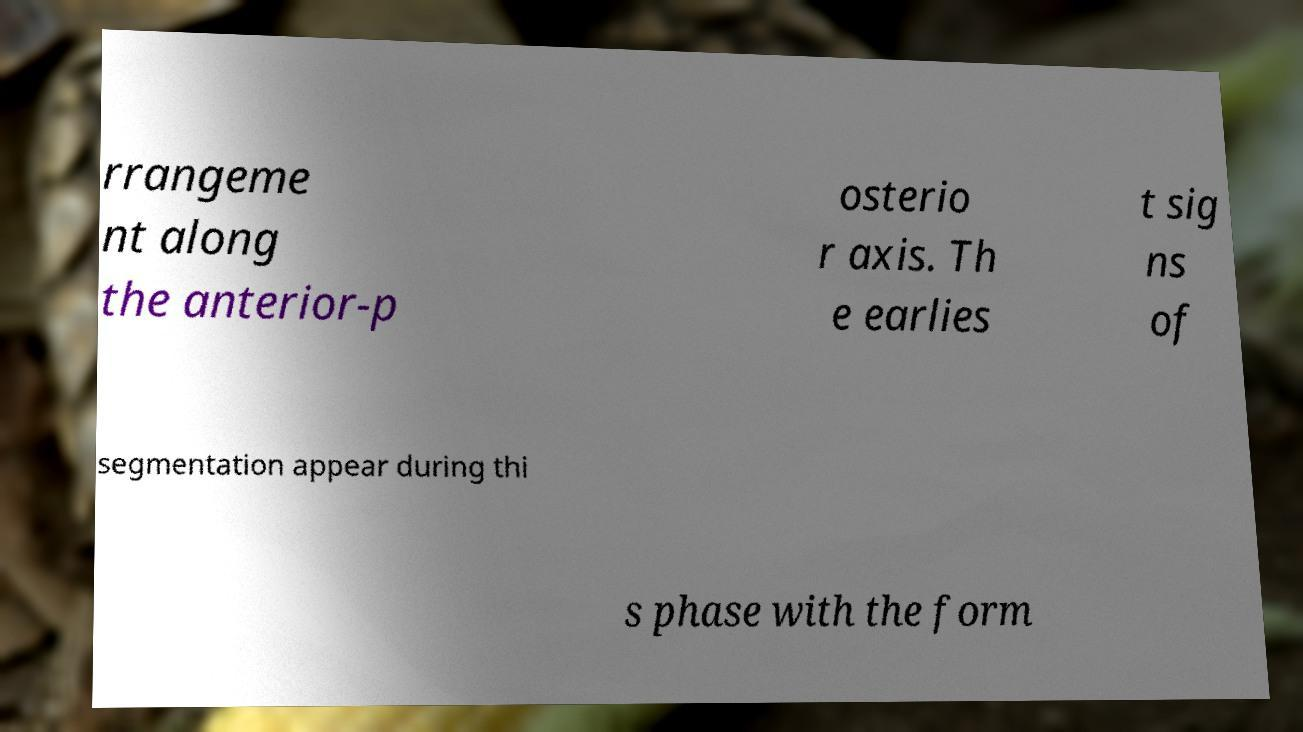Can you accurately transcribe the text from the provided image for me? rrangeme nt along the anterior-p osterio r axis. Th e earlies t sig ns of segmentation appear during thi s phase with the form 